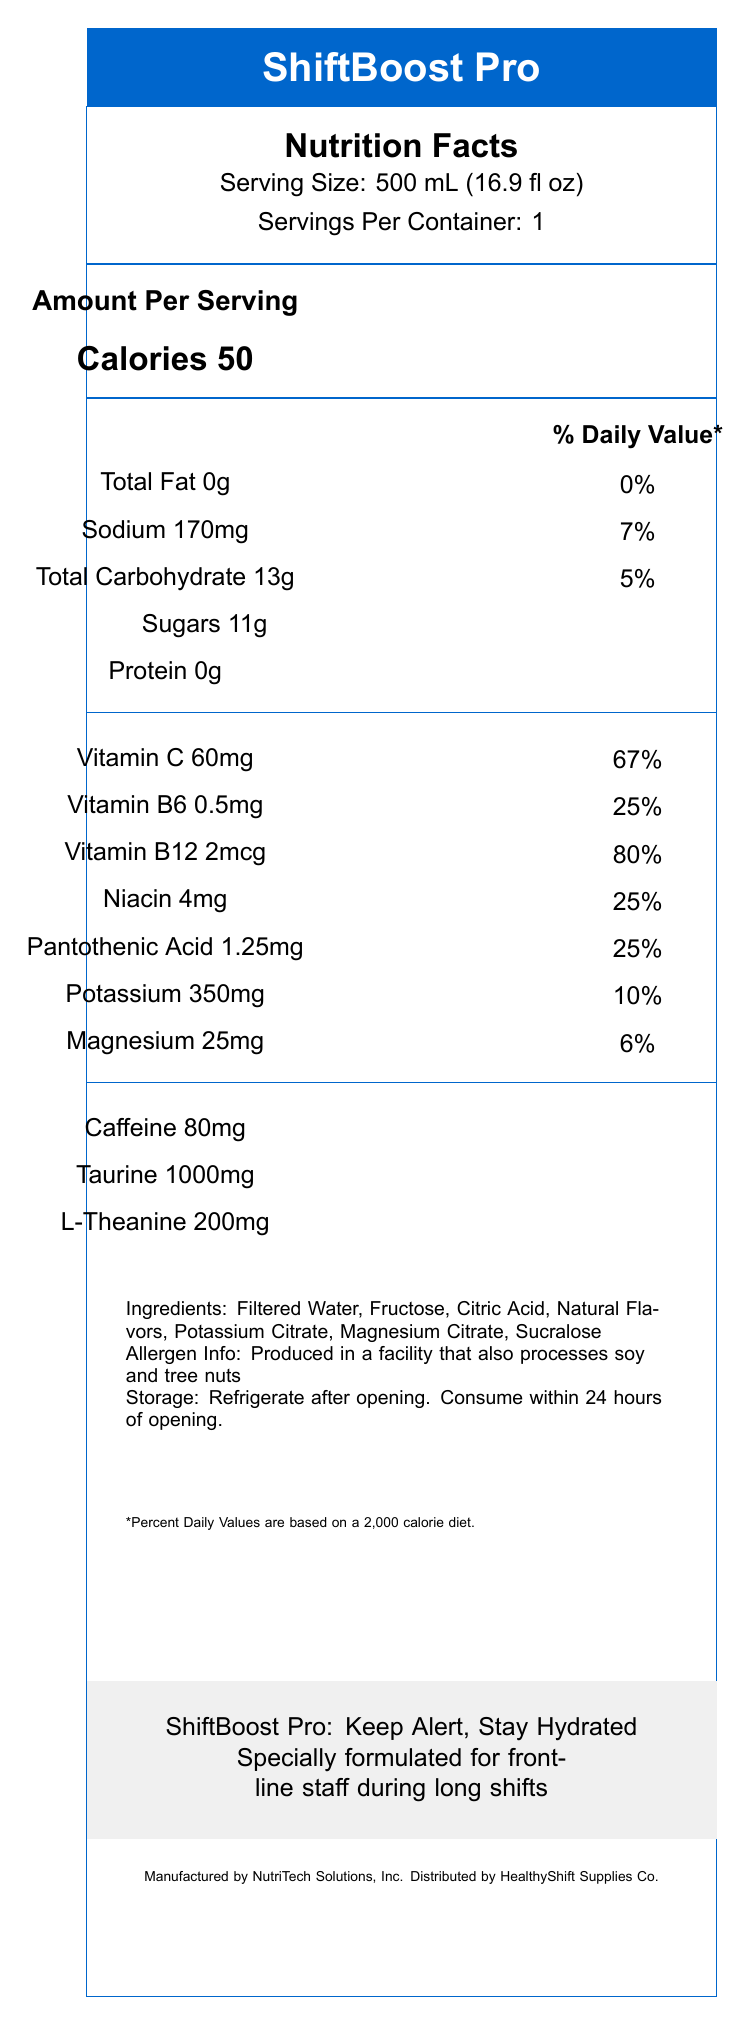What is the serving size of ShiftBoost Pro? The serving size is clearly listed as "500 mL (16.9 fl oz)" on the document.
Answer: 500 mL (16.9 fl oz) How many servings are there per container? The document states "Servings Per Container: 1".
Answer: 1 What is the amount of sodium per serving in ShiftBoost Pro? The document lists "Sodium 170mg" in the nutrition facts section.
Answer: 170 mg How much caffeine does each serving of ShiftBoost Pro contain? The nutrition facts section specifically mentions "Caffeine 80mg".
Answer: 80 mg Does ShiftBoost Pro contain any protein? The document shows "Protein 0g" indicating that there is no protein in the product.
Answer: No (1) What are the main vitamins included in ShiftBoost Pro? A. Vitamin A, Vitamin D, Vitamin E B. Vitamin C, Vitamin B6, Vitamin B12 C. Vitamin K, Vitamin B1, Vitamin D The vitamins primarily mentioned are Vitamin C, Vitamin B6, and Vitamin B12.
Answer: B (2) What are the key benefits of consuming ShiftBoost Pro? A. Enhanced digestion, Improved sleep B. Calorie control, Weight loss C. Sustained energy without jitters, Enhanced mental focus The key benefits listed include "Sustained energy without jitters" and "Enhanced mental focus".
Answer: C Is the product catered towards frontline staff working in less demanding industries? The target audience explicitly mentions working long or overnight shifts in demanding industries such as healthcare, security, and manufacturing.
Answer: No Summarize the main purpose of ShiftBoost Pro. The product is specially formulated to maintain focus and stamina without the crash associated with sugary energy drinks, making it ideal for demanding industries.
Answer: ShiftBoost Pro is designed to keep frontline staff alert and hydrated during long shifts by providing a balanced blend of electrolytes, vitamins, and energy boosters. What is the recommended consumption frequency for ShiftBoost Pro during shifts? The document suggests consuming "one bottle per 4-6 hour shift, or as needed to maintain hydration and alertness."
Answer: One bottle per 4-6 hours or as needed Does the document provide information about the calorie content in ShiftBoost Pro? The document states "Calories 50" in the nutrition facts section.
Answer: Yes, 50 calories per serving What are some examples of additional ingredients listed for ShiftBoost Pro? The document includes a list of other ingredients such as "Filtered Water, Fructose, Citric Acid".
Answer: Filtered Water, Fructose, Citric Acid Is this product produced in a facility that processes dairy products? The document mentions processing soy and tree nuts but does not mention anything about dairy products.
Answer: Cannot be determined What percentage of the daily value for Vitamin C does one serving of ShiftBoost Pro provide? The document lists "Vitamin C 60mg" which is 67% of the Daily Value.
Answer: 67% What is the main energy-boosting ingredient in ShiftBoost Pro aside from caffeine? The document lists "Taurine 1000mg" in the nutrition facts section, which is another primary energy-boosting ingredient.
Answer: Taurine 